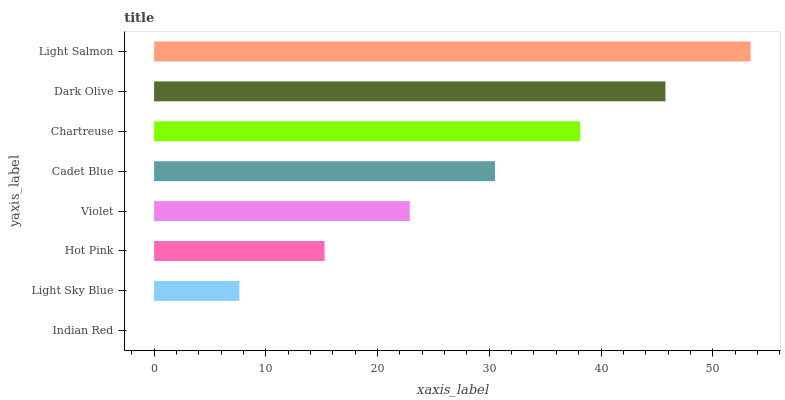Is Indian Red the minimum?
Answer yes or no. Yes. Is Light Salmon the maximum?
Answer yes or no. Yes. Is Light Sky Blue the minimum?
Answer yes or no. No. Is Light Sky Blue the maximum?
Answer yes or no. No. Is Light Sky Blue greater than Indian Red?
Answer yes or no. Yes. Is Indian Red less than Light Sky Blue?
Answer yes or no. Yes. Is Indian Red greater than Light Sky Blue?
Answer yes or no. No. Is Light Sky Blue less than Indian Red?
Answer yes or no. No. Is Cadet Blue the high median?
Answer yes or no. Yes. Is Violet the low median?
Answer yes or no. Yes. Is Indian Red the high median?
Answer yes or no. No. Is Hot Pink the low median?
Answer yes or no. No. 